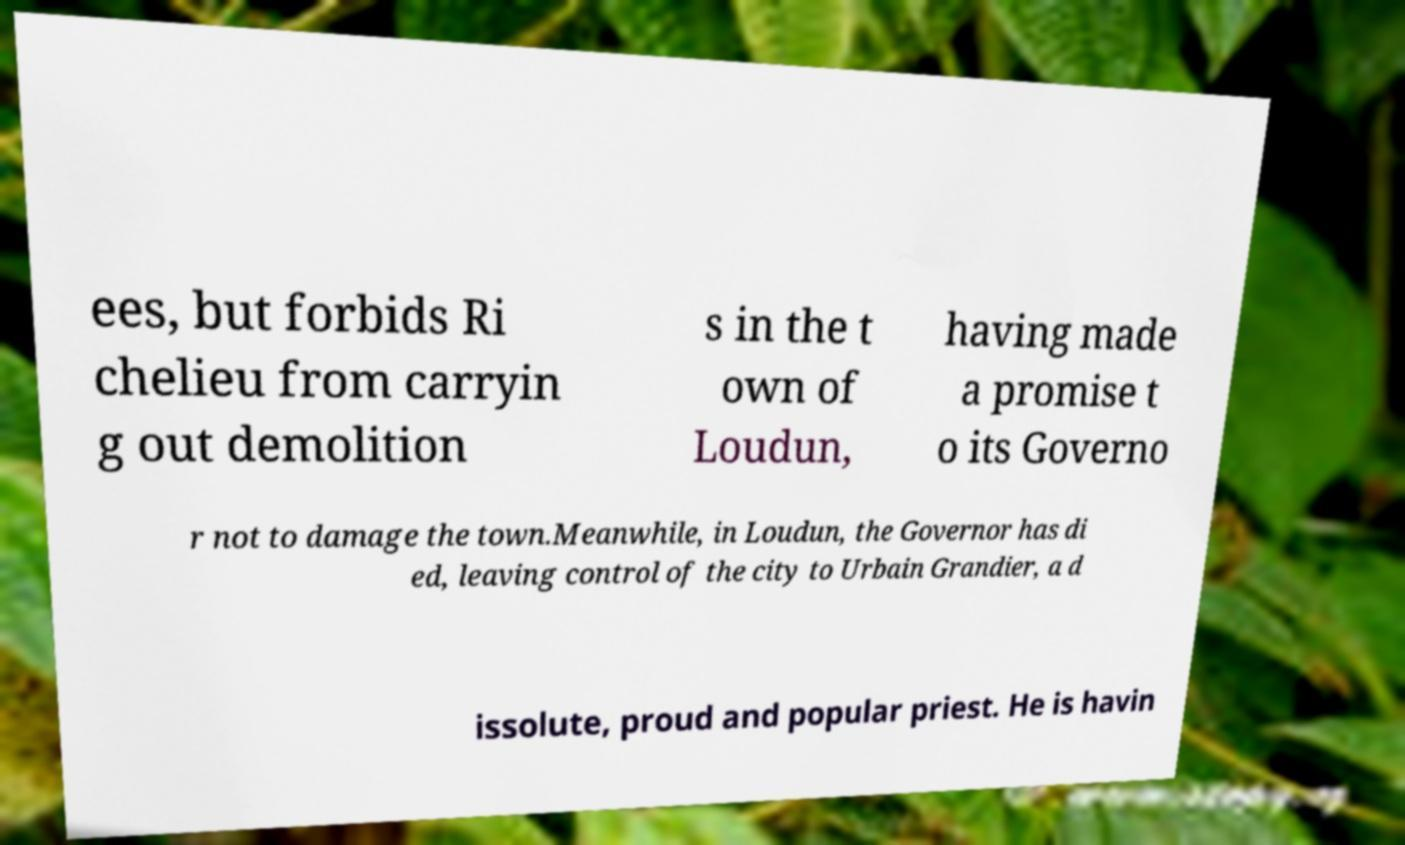Please identify and transcribe the text found in this image. ees, but forbids Ri chelieu from carryin g out demolition s in the t own of Loudun, having made a promise t o its Governo r not to damage the town.Meanwhile, in Loudun, the Governor has di ed, leaving control of the city to Urbain Grandier, a d issolute, proud and popular priest. He is havin 